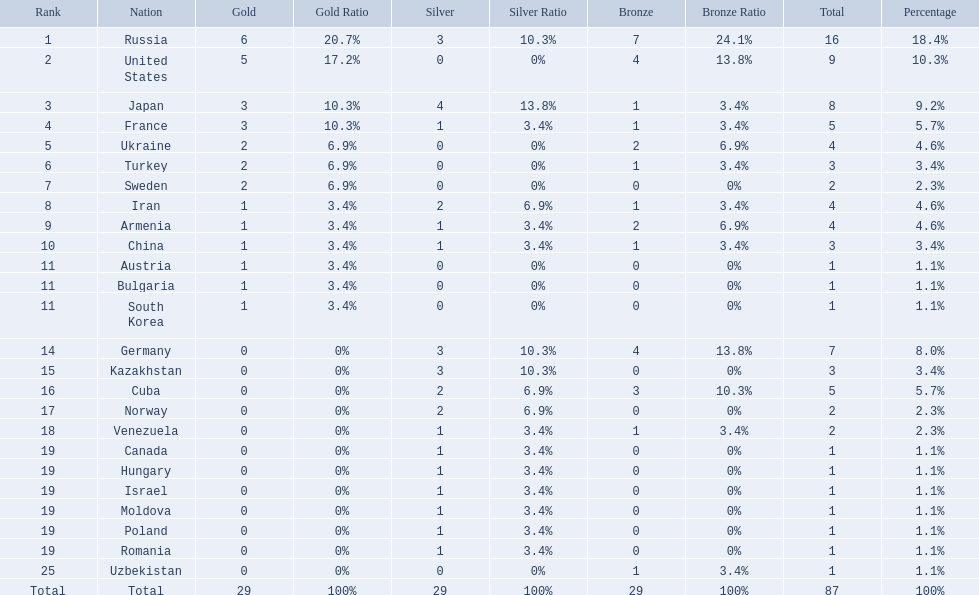What was iran's ranking? 8. What was germany's ranking? 14. Between iran and germany, which was not in the top 10? Germany. 